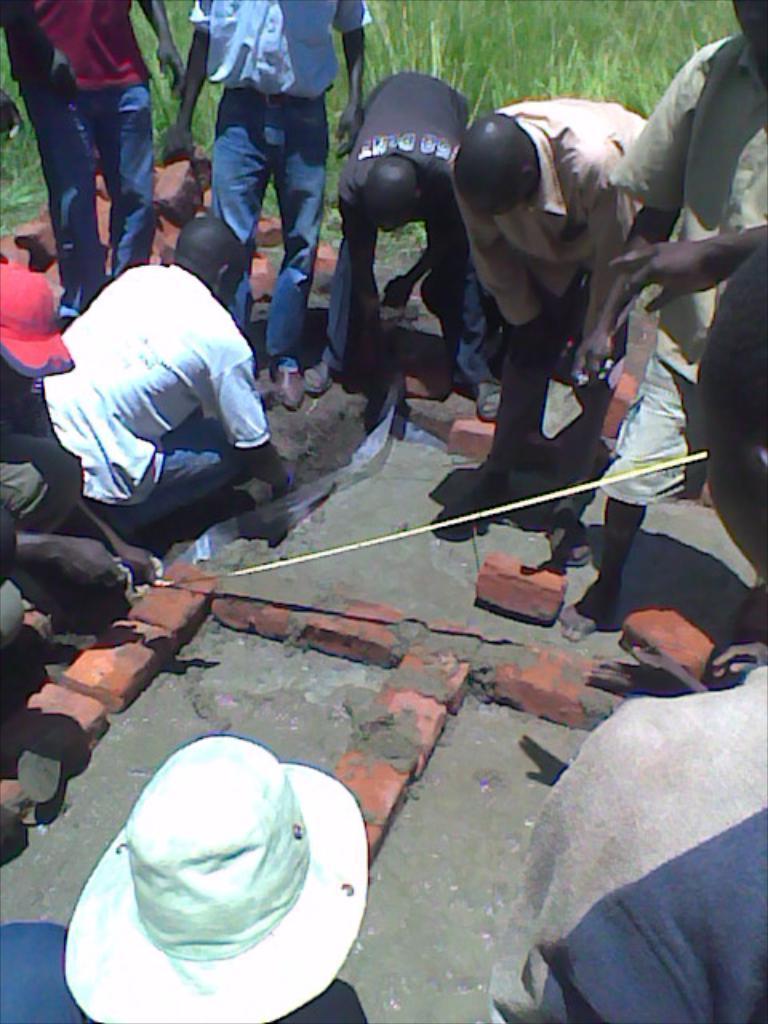Could you give a brief overview of what you see in this image? In this image there are some persons are standing in middle of this image and there are some persons are at bottom of this image and there is some grass at top of this image. 